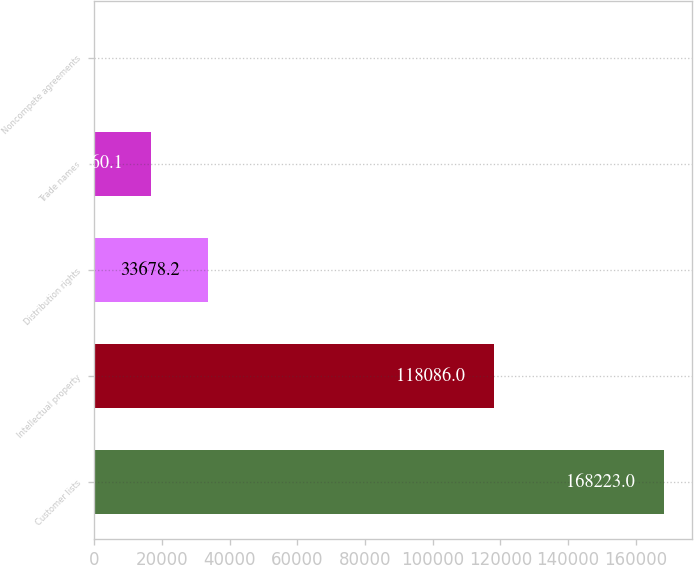<chart> <loc_0><loc_0><loc_500><loc_500><bar_chart><fcel>Customer lists<fcel>Intellectual property<fcel>Distribution rights<fcel>Trade names<fcel>Noncompete agreements<nl><fcel>168223<fcel>118086<fcel>33678.2<fcel>16860.1<fcel>42<nl></chart> 